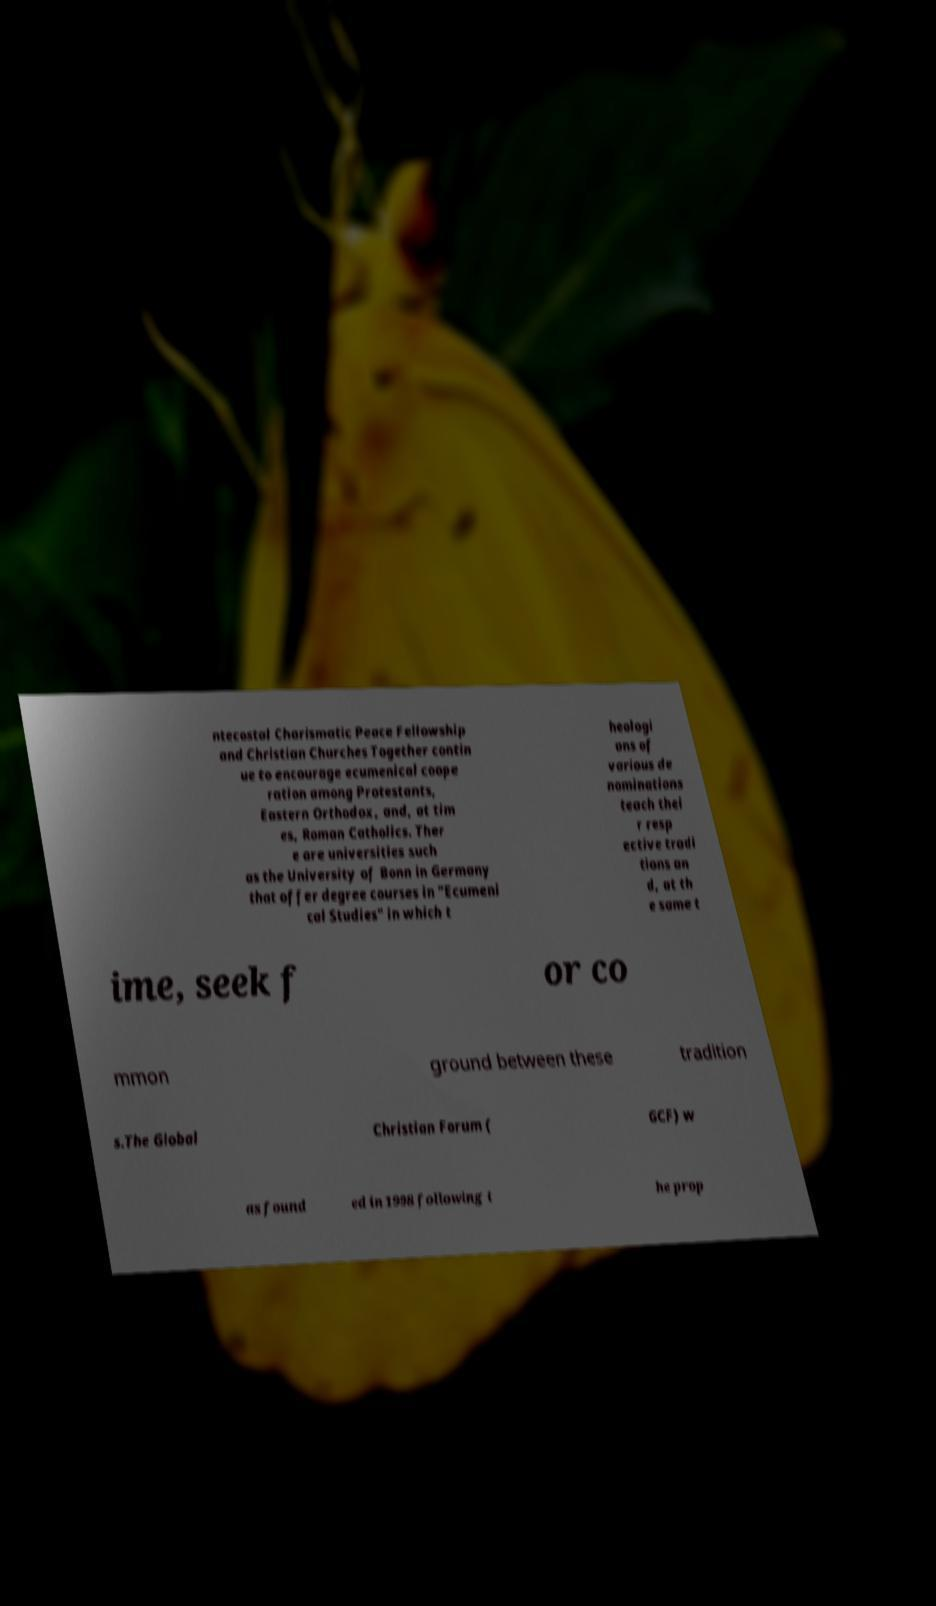There's text embedded in this image that I need extracted. Can you transcribe it verbatim? ntecostal Charismatic Peace Fellowship and Christian Churches Together contin ue to encourage ecumenical coope ration among Protestants, Eastern Orthodox, and, at tim es, Roman Catholics. Ther e are universities such as the University of Bonn in Germany that offer degree courses in "Ecumeni cal Studies" in which t heologi ans of various de nominations teach thei r resp ective tradi tions an d, at th e same t ime, seek f or co mmon ground between these tradition s.The Global Christian Forum ( GCF) w as found ed in 1998 following t he prop 